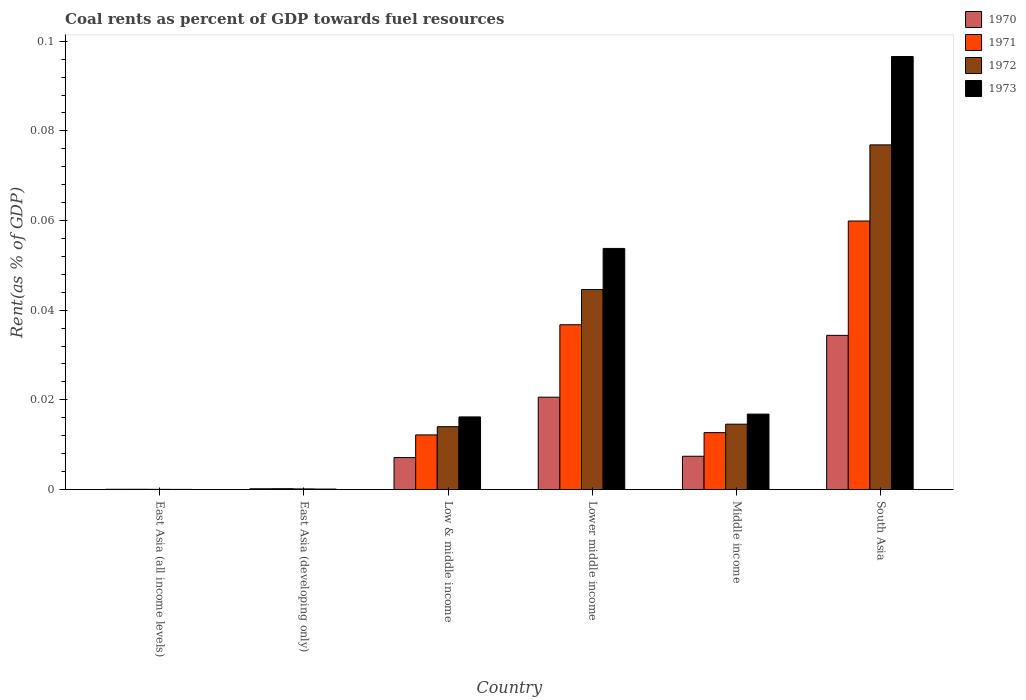How many different coloured bars are there?
Offer a terse response. 4. What is the label of the 5th group of bars from the left?
Your answer should be compact. Middle income. In how many cases, is the number of bars for a given country not equal to the number of legend labels?
Your answer should be very brief. 0. What is the coal rent in 1970 in Low & middle income?
Give a very brief answer. 0.01. Across all countries, what is the maximum coal rent in 1971?
Provide a succinct answer. 0.06. Across all countries, what is the minimum coal rent in 1970?
Give a very brief answer. 5.1314079013758e-5. In which country was the coal rent in 1970 minimum?
Make the answer very short. East Asia (all income levels). What is the total coal rent in 1972 in the graph?
Your answer should be compact. 0.15. What is the difference between the coal rent in 1970 in East Asia (all income levels) and that in East Asia (developing only)?
Make the answer very short. -0. What is the difference between the coal rent in 1970 in Lower middle income and the coal rent in 1972 in East Asia (developing only)?
Ensure brevity in your answer.  0.02. What is the average coal rent in 1970 per country?
Provide a succinct answer. 0.01. What is the difference between the coal rent of/in 1970 and coal rent of/in 1972 in Low & middle income?
Ensure brevity in your answer.  -0.01. What is the ratio of the coal rent in 1971 in East Asia (developing only) to that in Low & middle income?
Provide a succinct answer. 0.02. Is the coal rent in 1973 in East Asia (all income levels) less than that in East Asia (developing only)?
Ensure brevity in your answer.  Yes. What is the difference between the highest and the second highest coal rent in 1971?
Give a very brief answer. 0.05. What is the difference between the highest and the lowest coal rent in 1970?
Keep it short and to the point. 0.03. Is it the case that in every country, the sum of the coal rent in 1971 and coal rent in 1972 is greater than the sum of coal rent in 1973 and coal rent in 1970?
Your answer should be compact. No. What does the 4th bar from the left in Lower middle income represents?
Make the answer very short. 1973. Is it the case that in every country, the sum of the coal rent in 1973 and coal rent in 1972 is greater than the coal rent in 1971?
Your answer should be very brief. Yes. Are all the bars in the graph horizontal?
Your answer should be very brief. No. How many countries are there in the graph?
Offer a very short reply. 6. How are the legend labels stacked?
Your answer should be very brief. Vertical. What is the title of the graph?
Offer a terse response. Coal rents as percent of GDP towards fuel resources. Does "2006" appear as one of the legend labels in the graph?
Keep it short and to the point. No. What is the label or title of the Y-axis?
Keep it short and to the point. Rent(as % of GDP). What is the Rent(as % of GDP) of 1970 in East Asia (all income levels)?
Keep it short and to the point. 5.1314079013758e-5. What is the Rent(as % of GDP) in 1971 in East Asia (all income levels)?
Keep it short and to the point. 5.470114168356261e-5. What is the Rent(as % of GDP) in 1972 in East Asia (all income levels)?
Keep it short and to the point. 3.67730514806032e-5. What is the Rent(as % of GDP) of 1973 in East Asia (all income levels)?
Offer a terse response. 2.64171247686014e-5. What is the Rent(as % of GDP) of 1970 in East Asia (developing only)?
Offer a very short reply. 0. What is the Rent(as % of GDP) of 1971 in East Asia (developing only)?
Provide a short and direct response. 0. What is the Rent(as % of GDP) in 1972 in East Asia (developing only)?
Your answer should be compact. 0. What is the Rent(as % of GDP) of 1973 in East Asia (developing only)?
Make the answer very short. 0. What is the Rent(as % of GDP) of 1970 in Low & middle income?
Offer a very short reply. 0.01. What is the Rent(as % of GDP) in 1971 in Low & middle income?
Keep it short and to the point. 0.01. What is the Rent(as % of GDP) of 1972 in Low & middle income?
Provide a succinct answer. 0.01. What is the Rent(as % of GDP) in 1973 in Low & middle income?
Ensure brevity in your answer.  0.02. What is the Rent(as % of GDP) in 1970 in Lower middle income?
Your response must be concise. 0.02. What is the Rent(as % of GDP) of 1971 in Lower middle income?
Ensure brevity in your answer.  0.04. What is the Rent(as % of GDP) of 1972 in Lower middle income?
Keep it short and to the point. 0.04. What is the Rent(as % of GDP) of 1973 in Lower middle income?
Your answer should be very brief. 0.05. What is the Rent(as % of GDP) of 1970 in Middle income?
Provide a short and direct response. 0.01. What is the Rent(as % of GDP) of 1971 in Middle income?
Make the answer very short. 0.01. What is the Rent(as % of GDP) in 1972 in Middle income?
Make the answer very short. 0.01. What is the Rent(as % of GDP) in 1973 in Middle income?
Your answer should be compact. 0.02. What is the Rent(as % of GDP) of 1970 in South Asia?
Keep it short and to the point. 0.03. What is the Rent(as % of GDP) of 1971 in South Asia?
Your answer should be very brief. 0.06. What is the Rent(as % of GDP) in 1972 in South Asia?
Make the answer very short. 0.08. What is the Rent(as % of GDP) in 1973 in South Asia?
Ensure brevity in your answer.  0.1. Across all countries, what is the maximum Rent(as % of GDP) of 1970?
Your response must be concise. 0.03. Across all countries, what is the maximum Rent(as % of GDP) in 1971?
Your answer should be compact. 0.06. Across all countries, what is the maximum Rent(as % of GDP) in 1972?
Provide a succinct answer. 0.08. Across all countries, what is the maximum Rent(as % of GDP) in 1973?
Give a very brief answer. 0.1. Across all countries, what is the minimum Rent(as % of GDP) of 1970?
Provide a short and direct response. 5.1314079013758e-5. Across all countries, what is the minimum Rent(as % of GDP) in 1971?
Your answer should be very brief. 5.470114168356261e-5. Across all countries, what is the minimum Rent(as % of GDP) of 1972?
Ensure brevity in your answer.  3.67730514806032e-5. Across all countries, what is the minimum Rent(as % of GDP) of 1973?
Your response must be concise. 2.64171247686014e-5. What is the total Rent(as % of GDP) in 1970 in the graph?
Make the answer very short. 0.07. What is the total Rent(as % of GDP) in 1971 in the graph?
Your answer should be very brief. 0.12. What is the total Rent(as % of GDP) in 1972 in the graph?
Provide a succinct answer. 0.15. What is the total Rent(as % of GDP) of 1973 in the graph?
Your response must be concise. 0.18. What is the difference between the Rent(as % of GDP) of 1970 in East Asia (all income levels) and that in East Asia (developing only)?
Make the answer very short. -0. What is the difference between the Rent(as % of GDP) of 1971 in East Asia (all income levels) and that in East Asia (developing only)?
Ensure brevity in your answer.  -0. What is the difference between the Rent(as % of GDP) of 1972 in East Asia (all income levels) and that in East Asia (developing only)?
Offer a very short reply. -0. What is the difference between the Rent(as % of GDP) in 1973 in East Asia (all income levels) and that in East Asia (developing only)?
Offer a very short reply. -0. What is the difference between the Rent(as % of GDP) in 1970 in East Asia (all income levels) and that in Low & middle income?
Make the answer very short. -0.01. What is the difference between the Rent(as % of GDP) in 1971 in East Asia (all income levels) and that in Low & middle income?
Your response must be concise. -0.01. What is the difference between the Rent(as % of GDP) in 1972 in East Asia (all income levels) and that in Low & middle income?
Your response must be concise. -0.01. What is the difference between the Rent(as % of GDP) in 1973 in East Asia (all income levels) and that in Low & middle income?
Ensure brevity in your answer.  -0.02. What is the difference between the Rent(as % of GDP) of 1970 in East Asia (all income levels) and that in Lower middle income?
Ensure brevity in your answer.  -0.02. What is the difference between the Rent(as % of GDP) of 1971 in East Asia (all income levels) and that in Lower middle income?
Provide a short and direct response. -0.04. What is the difference between the Rent(as % of GDP) of 1972 in East Asia (all income levels) and that in Lower middle income?
Make the answer very short. -0.04. What is the difference between the Rent(as % of GDP) of 1973 in East Asia (all income levels) and that in Lower middle income?
Give a very brief answer. -0.05. What is the difference between the Rent(as % of GDP) of 1970 in East Asia (all income levels) and that in Middle income?
Offer a very short reply. -0.01. What is the difference between the Rent(as % of GDP) of 1971 in East Asia (all income levels) and that in Middle income?
Offer a very short reply. -0.01. What is the difference between the Rent(as % of GDP) in 1972 in East Asia (all income levels) and that in Middle income?
Your response must be concise. -0.01. What is the difference between the Rent(as % of GDP) in 1973 in East Asia (all income levels) and that in Middle income?
Keep it short and to the point. -0.02. What is the difference between the Rent(as % of GDP) of 1970 in East Asia (all income levels) and that in South Asia?
Make the answer very short. -0.03. What is the difference between the Rent(as % of GDP) in 1971 in East Asia (all income levels) and that in South Asia?
Keep it short and to the point. -0.06. What is the difference between the Rent(as % of GDP) in 1972 in East Asia (all income levels) and that in South Asia?
Your answer should be compact. -0.08. What is the difference between the Rent(as % of GDP) of 1973 in East Asia (all income levels) and that in South Asia?
Offer a terse response. -0.1. What is the difference between the Rent(as % of GDP) of 1970 in East Asia (developing only) and that in Low & middle income?
Ensure brevity in your answer.  -0.01. What is the difference between the Rent(as % of GDP) of 1971 in East Asia (developing only) and that in Low & middle income?
Offer a very short reply. -0.01. What is the difference between the Rent(as % of GDP) in 1972 in East Asia (developing only) and that in Low & middle income?
Offer a terse response. -0.01. What is the difference between the Rent(as % of GDP) of 1973 in East Asia (developing only) and that in Low & middle income?
Offer a terse response. -0.02. What is the difference between the Rent(as % of GDP) in 1970 in East Asia (developing only) and that in Lower middle income?
Your answer should be compact. -0.02. What is the difference between the Rent(as % of GDP) of 1971 in East Asia (developing only) and that in Lower middle income?
Your answer should be compact. -0.04. What is the difference between the Rent(as % of GDP) in 1972 in East Asia (developing only) and that in Lower middle income?
Offer a very short reply. -0.04. What is the difference between the Rent(as % of GDP) of 1973 in East Asia (developing only) and that in Lower middle income?
Your answer should be compact. -0.05. What is the difference between the Rent(as % of GDP) in 1970 in East Asia (developing only) and that in Middle income?
Offer a very short reply. -0.01. What is the difference between the Rent(as % of GDP) in 1971 in East Asia (developing only) and that in Middle income?
Your response must be concise. -0.01. What is the difference between the Rent(as % of GDP) in 1972 in East Asia (developing only) and that in Middle income?
Keep it short and to the point. -0.01. What is the difference between the Rent(as % of GDP) in 1973 in East Asia (developing only) and that in Middle income?
Ensure brevity in your answer.  -0.02. What is the difference between the Rent(as % of GDP) of 1970 in East Asia (developing only) and that in South Asia?
Give a very brief answer. -0.03. What is the difference between the Rent(as % of GDP) in 1971 in East Asia (developing only) and that in South Asia?
Make the answer very short. -0.06. What is the difference between the Rent(as % of GDP) of 1972 in East Asia (developing only) and that in South Asia?
Make the answer very short. -0.08. What is the difference between the Rent(as % of GDP) in 1973 in East Asia (developing only) and that in South Asia?
Offer a very short reply. -0.1. What is the difference between the Rent(as % of GDP) in 1970 in Low & middle income and that in Lower middle income?
Your response must be concise. -0.01. What is the difference between the Rent(as % of GDP) of 1971 in Low & middle income and that in Lower middle income?
Offer a terse response. -0.02. What is the difference between the Rent(as % of GDP) in 1972 in Low & middle income and that in Lower middle income?
Ensure brevity in your answer.  -0.03. What is the difference between the Rent(as % of GDP) of 1973 in Low & middle income and that in Lower middle income?
Make the answer very short. -0.04. What is the difference between the Rent(as % of GDP) in 1970 in Low & middle income and that in Middle income?
Provide a short and direct response. -0. What is the difference between the Rent(as % of GDP) in 1971 in Low & middle income and that in Middle income?
Provide a short and direct response. -0. What is the difference between the Rent(as % of GDP) of 1972 in Low & middle income and that in Middle income?
Make the answer very short. -0. What is the difference between the Rent(as % of GDP) in 1973 in Low & middle income and that in Middle income?
Keep it short and to the point. -0. What is the difference between the Rent(as % of GDP) of 1970 in Low & middle income and that in South Asia?
Your answer should be compact. -0.03. What is the difference between the Rent(as % of GDP) of 1971 in Low & middle income and that in South Asia?
Your response must be concise. -0.05. What is the difference between the Rent(as % of GDP) in 1972 in Low & middle income and that in South Asia?
Your answer should be compact. -0.06. What is the difference between the Rent(as % of GDP) in 1973 in Low & middle income and that in South Asia?
Offer a very short reply. -0.08. What is the difference between the Rent(as % of GDP) in 1970 in Lower middle income and that in Middle income?
Keep it short and to the point. 0.01. What is the difference between the Rent(as % of GDP) of 1971 in Lower middle income and that in Middle income?
Keep it short and to the point. 0.02. What is the difference between the Rent(as % of GDP) in 1973 in Lower middle income and that in Middle income?
Provide a short and direct response. 0.04. What is the difference between the Rent(as % of GDP) in 1970 in Lower middle income and that in South Asia?
Your answer should be compact. -0.01. What is the difference between the Rent(as % of GDP) of 1971 in Lower middle income and that in South Asia?
Provide a succinct answer. -0.02. What is the difference between the Rent(as % of GDP) of 1972 in Lower middle income and that in South Asia?
Keep it short and to the point. -0.03. What is the difference between the Rent(as % of GDP) in 1973 in Lower middle income and that in South Asia?
Provide a short and direct response. -0.04. What is the difference between the Rent(as % of GDP) of 1970 in Middle income and that in South Asia?
Keep it short and to the point. -0.03. What is the difference between the Rent(as % of GDP) of 1971 in Middle income and that in South Asia?
Provide a succinct answer. -0.05. What is the difference between the Rent(as % of GDP) in 1972 in Middle income and that in South Asia?
Your response must be concise. -0.06. What is the difference between the Rent(as % of GDP) of 1973 in Middle income and that in South Asia?
Your answer should be compact. -0.08. What is the difference between the Rent(as % of GDP) in 1970 in East Asia (all income levels) and the Rent(as % of GDP) in 1971 in East Asia (developing only)?
Provide a succinct answer. -0. What is the difference between the Rent(as % of GDP) of 1970 in East Asia (all income levels) and the Rent(as % of GDP) of 1972 in East Asia (developing only)?
Offer a very short reply. -0. What is the difference between the Rent(as % of GDP) in 1970 in East Asia (all income levels) and the Rent(as % of GDP) in 1973 in East Asia (developing only)?
Your response must be concise. -0. What is the difference between the Rent(as % of GDP) of 1971 in East Asia (all income levels) and the Rent(as % of GDP) of 1972 in East Asia (developing only)?
Your answer should be compact. -0. What is the difference between the Rent(as % of GDP) in 1972 in East Asia (all income levels) and the Rent(as % of GDP) in 1973 in East Asia (developing only)?
Provide a succinct answer. -0. What is the difference between the Rent(as % of GDP) of 1970 in East Asia (all income levels) and the Rent(as % of GDP) of 1971 in Low & middle income?
Offer a very short reply. -0.01. What is the difference between the Rent(as % of GDP) of 1970 in East Asia (all income levels) and the Rent(as % of GDP) of 1972 in Low & middle income?
Your response must be concise. -0.01. What is the difference between the Rent(as % of GDP) in 1970 in East Asia (all income levels) and the Rent(as % of GDP) in 1973 in Low & middle income?
Keep it short and to the point. -0.02. What is the difference between the Rent(as % of GDP) in 1971 in East Asia (all income levels) and the Rent(as % of GDP) in 1972 in Low & middle income?
Keep it short and to the point. -0.01. What is the difference between the Rent(as % of GDP) in 1971 in East Asia (all income levels) and the Rent(as % of GDP) in 1973 in Low & middle income?
Your answer should be compact. -0.02. What is the difference between the Rent(as % of GDP) of 1972 in East Asia (all income levels) and the Rent(as % of GDP) of 1973 in Low & middle income?
Keep it short and to the point. -0.02. What is the difference between the Rent(as % of GDP) in 1970 in East Asia (all income levels) and the Rent(as % of GDP) in 1971 in Lower middle income?
Provide a short and direct response. -0.04. What is the difference between the Rent(as % of GDP) in 1970 in East Asia (all income levels) and the Rent(as % of GDP) in 1972 in Lower middle income?
Offer a terse response. -0.04. What is the difference between the Rent(as % of GDP) of 1970 in East Asia (all income levels) and the Rent(as % of GDP) of 1973 in Lower middle income?
Your response must be concise. -0.05. What is the difference between the Rent(as % of GDP) of 1971 in East Asia (all income levels) and the Rent(as % of GDP) of 1972 in Lower middle income?
Your response must be concise. -0.04. What is the difference between the Rent(as % of GDP) of 1971 in East Asia (all income levels) and the Rent(as % of GDP) of 1973 in Lower middle income?
Your answer should be very brief. -0.05. What is the difference between the Rent(as % of GDP) of 1972 in East Asia (all income levels) and the Rent(as % of GDP) of 1973 in Lower middle income?
Keep it short and to the point. -0.05. What is the difference between the Rent(as % of GDP) of 1970 in East Asia (all income levels) and the Rent(as % of GDP) of 1971 in Middle income?
Your answer should be very brief. -0.01. What is the difference between the Rent(as % of GDP) in 1970 in East Asia (all income levels) and the Rent(as % of GDP) in 1972 in Middle income?
Provide a short and direct response. -0.01. What is the difference between the Rent(as % of GDP) in 1970 in East Asia (all income levels) and the Rent(as % of GDP) in 1973 in Middle income?
Your response must be concise. -0.02. What is the difference between the Rent(as % of GDP) in 1971 in East Asia (all income levels) and the Rent(as % of GDP) in 1972 in Middle income?
Offer a very short reply. -0.01. What is the difference between the Rent(as % of GDP) of 1971 in East Asia (all income levels) and the Rent(as % of GDP) of 1973 in Middle income?
Your answer should be compact. -0.02. What is the difference between the Rent(as % of GDP) of 1972 in East Asia (all income levels) and the Rent(as % of GDP) of 1973 in Middle income?
Offer a very short reply. -0.02. What is the difference between the Rent(as % of GDP) in 1970 in East Asia (all income levels) and the Rent(as % of GDP) in 1971 in South Asia?
Your response must be concise. -0.06. What is the difference between the Rent(as % of GDP) of 1970 in East Asia (all income levels) and the Rent(as % of GDP) of 1972 in South Asia?
Provide a short and direct response. -0.08. What is the difference between the Rent(as % of GDP) of 1970 in East Asia (all income levels) and the Rent(as % of GDP) of 1973 in South Asia?
Provide a short and direct response. -0.1. What is the difference between the Rent(as % of GDP) in 1971 in East Asia (all income levels) and the Rent(as % of GDP) in 1972 in South Asia?
Give a very brief answer. -0.08. What is the difference between the Rent(as % of GDP) in 1971 in East Asia (all income levels) and the Rent(as % of GDP) in 1973 in South Asia?
Provide a short and direct response. -0.1. What is the difference between the Rent(as % of GDP) of 1972 in East Asia (all income levels) and the Rent(as % of GDP) of 1973 in South Asia?
Provide a succinct answer. -0.1. What is the difference between the Rent(as % of GDP) of 1970 in East Asia (developing only) and the Rent(as % of GDP) of 1971 in Low & middle income?
Provide a succinct answer. -0.01. What is the difference between the Rent(as % of GDP) of 1970 in East Asia (developing only) and the Rent(as % of GDP) of 1972 in Low & middle income?
Offer a terse response. -0.01. What is the difference between the Rent(as % of GDP) in 1970 in East Asia (developing only) and the Rent(as % of GDP) in 1973 in Low & middle income?
Provide a succinct answer. -0.02. What is the difference between the Rent(as % of GDP) of 1971 in East Asia (developing only) and the Rent(as % of GDP) of 1972 in Low & middle income?
Your answer should be compact. -0.01. What is the difference between the Rent(as % of GDP) of 1971 in East Asia (developing only) and the Rent(as % of GDP) of 1973 in Low & middle income?
Offer a terse response. -0.02. What is the difference between the Rent(as % of GDP) of 1972 in East Asia (developing only) and the Rent(as % of GDP) of 1973 in Low & middle income?
Offer a very short reply. -0.02. What is the difference between the Rent(as % of GDP) in 1970 in East Asia (developing only) and the Rent(as % of GDP) in 1971 in Lower middle income?
Make the answer very short. -0.04. What is the difference between the Rent(as % of GDP) in 1970 in East Asia (developing only) and the Rent(as % of GDP) in 1972 in Lower middle income?
Provide a succinct answer. -0.04. What is the difference between the Rent(as % of GDP) of 1970 in East Asia (developing only) and the Rent(as % of GDP) of 1973 in Lower middle income?
Your answer should be compact. -0.05. What is the difference between the Rent(as % of GDP) in 1971 in East Asia (developing only) and the Rent(as % of GDP) in 1972 in Lower middle income?
Your answer should be compact. -0.04. What is the difference between the Rent(as % of GDP) of 1971 in East Asia (developing only) and the Rent(as % of GDP) of 1973 in Lower middle income?
Make the answer very short. -0.05. What is the difference between the Rent(as % of GDP) in 1972 in East Asia (developing only) and the Rent(as % of GDP) in 1973 in Lower middle income?
Give a very brief answer. -0.05. What is the difference between the Rent(as % of GDP) in 1970 in East Asia (developing only) and the Rent(as % of GDP) in 1971 in Middle income?
Provide a short and direct response. -0.01. What is the difference between the Rent(as % of GDP) of 1970 in East Asia (developing only) and the Rent(as % of GDP) of 1972 in Middle income?
Provide a short and direct response. -0.01. What is the difference between the Rent(as % of GDP) of 1970 in East Asia (developing only) and the Rent(as % of GDP) of 1973 in Middle income?
Offer a very short reply. -0.02. What is the difference between the Rent(as % of GDP) of 1971 in East Asia (developing only) and the Rent(as % of GDP) of 1972 in Middle income?
Provide a succinct answer. -0.01. What is the difference between the Rent(as % of GDP) in 1971 in East Asia (developing only) and the Rent(as % of GDP) in 1973 in Middle income?
Your response must be concise. -0.02. What is the difference between the Rent(as % of GDP) of 1972 in East Asia (developing only) and the Rent(as % of GDP) of 1973 in Middle income?
Keep it short and to the point. -0.02. What is the difference between the Rent(as % of GDP) of 1970 in East Asia (developing only) and the Rent(as % of GDP) of 1971 in South Asia?
Your answer should be very brief. -0.06. What is the difference between the Rent(as % of GDP) in 1970 in East Asia (developing only) and the Rent(as % of GDP) in 1972 in South Asia?
Your answer should be compact. -0.08. What is the difference between the Rent(as % of GDP) of 1970 in East Asia (developing only) and the Rent(as % of GDP) of 1973 in South Asia?
Provide a short and direct response. -0.1. What is the difference between the Rent(as % of GDP) in 1971 in East Asia (developing only) and the Rent(as % of GDP) in 1972 in South Asia?
Your answer should be very brief. -0.08. What is the difference between the Rent(as % of GDP) in 1971 in East Asia (developing only) and the Rent(as % of GDP) in 1973 in South Asia?
Offer a terse response. -0.1. What is the difference between the Rent(as % of GDP) in 1972 in East Asia (developing only) and the Rent(as % of GDP) in 1973 in South Asia?
Provide a succinct answer. -0.1. What is the difference between the Rent(as % of GDP) in 1970 in Low & middle income and the Rent(as % of GDP) in 1971 in Lower middle income?
Provide a succinct answer. -0.03. What is the difference between the Rent(as % of GDP) in 1970 in Low & middle income and the Rent(as % of GDP) in 1972 in Lower middle income?
Offer a terse response. -0.04. What is the difference between the Rent(as % of GDP) of 1970 in Low & middle income and the Rent(as % of GDP) of 1973 in Lower middle income?
Give a very brief answer. -0.05. What is the difference between the Rent(as % of GDP) in 1971 in Low & middle income and the Rent(as % of GDP) in 1972 in Lower middle income?
Offer a terse response. -0.03. What is the difference between the Rent(as % of GDP) in 1971 in Low & middle income and the Rent(as % of GDP) in 1973 in Lower middle income?
Offer a very short reply. -0.04. What is the difference between the Rent(as % of GDP) of 1972 in Low & middle income and the Rent(as % of GDP) of 1973 in Lower middle income?
Your response must be concise. -0.04. What is the difference between the Rent(as % of GDP) in 1970 in Low & middle income and the Rent(as % of GDP) in 1971 in Middle income?
Make the answer very short. -0.01. What is the difference between the Rent(as % of GDP) in 1970 in Low & middle income and the Rent(as % of GDP) in 1972 in Middle income?
Provide a short and direct response. -0.01. What is the difference between the Rent(as % of GDP) of 1970 in Low & middle income and the Rent(as % of GDP) of 1973 in Middle income?
Your response must be concise. -0.01. What is the difference between the Rent(as % of GDP) of 1971 in Low & middle income and the Rent(as % of GDP) of 1972 in Middle income?
Your answer should be compact. -0. What is the difference between the Rent(as % of GDP) in 1971 in Low & middle income and the Rent(as % of GDP) in 1973 in Middle income?
Ensure brevity in your answer.  -0. What is the difference between the Rent(as % of GDP) in 1972 in Low & middle income and the Rent(as % of GDP) in 1973 in Middle income?
Provide a succinct answer. -0. What is the difference between the Rent(as % of GDP) of 1970 in Low & middle income and the Rent(as % of GDP) of 1971 in South Asia?
Provide a succinct answer. -0.05. What is the difference between the Rent(as % of GDP) in 1970 in Low & middle income and the Rent(as % of GDP) in 1972 in South Asia?
Give a very brief answer. -0.07. What is the difference between the Rent(as % of GDP) of 1970 in Low & middle income and the Rent(as % of GDP) of 1973 in South Asia?
Offer a terse response. -0.09. What is the difference between the Rent(as % of GDP) of 1971 in Low & middle income and the Rent(as % of GDP) of 1972 in South Asia?
Give a very brief answer. -0.06. What is the difference between the Rent(as % of GDP) of 1971 in Low & middle income and the Rent(as % of GDP) of 1973 in South Asia?
Ensure brevity in your answer.  -0.08. What is the difference between the Rent(as % of GDP) of 1972 in Low & middle income and the Rent(as % of GDP) of 1973 in South Asia?
Your answer should be compact. -0.08. What is the difference between the Rent(as % of GDP) of 1970 in Lower middle income and the Rent(as % of GDP) of 1971 in Middle income?
Provide a succinct answer. 0.01. What is the difference between the Rent(as % of GDP) in 1970 in Lower middle income and the Rent(as % of GDP) in 1972 in Middle income?
Your answer should be very brief. 0.01. What is the difference between the Rent(as % of GDP) of 1970 in Lower middle income and the Rent(as % of GDP) of 1973 in Middle income?
Provide a succinct answer. 0. What is the difference between the Rent(as % of GDP) in 1971 in Lower middle income and the Rent(as % of GDP) in 1972 in Middle income?
Provide a succinct answer. 0.02. What is the difference between the Rent(as % of GDP) in 1971 in Lower middle income and the Rent(as % of GDP) in 1973 in Middle income?
Your response must be concise. 0.02. What is the difference between the Rent(as % of GDP) in 1972 in Lower middle income and the Rent(as % of GDP) in 1973 in Middle income?
Give a very brief answer. 0.03. What is the difference between the Rent(as % of GDP) of 1970 in Lower middle income and the Rent(as % of GDP) of 1971 in South Asia?
Offer a terse response. -0.04. What is the difference between the Rent(as % of GDP) in 1970 in Lower middle income and the Rent(as % of GDP) in 1972 in South Asia?
Offer a terse response. -0.06. What is the difference between the Rent(as % of GDP) in 1970 in Lower middle income and the Rent(as % of GDP) in 1973 in South Asia?
Your response must be concise. -0.08. What is the difference between the Rent(as % of GDP) of 1971 in Lower middle income and the Rent(as % of GDP) of 1972 in South Asia?
Your answer should be very brief. -0.04. What is the difference between the Rent(as % of GDP) of 1971 in Lower middle income and the Rent(as % of GDP) of 1973 in South Asia?
Your response must be concise. -0.06. What is the difference between the Rent(as % of GDP) in 1972 in Lower middle income and the Rent(as % of GDP) in 1973 in South Asia?
Provide a succinct answer. -0.05. What is the difference between the Rent(as % of GDP) in 1970 in Middle income and the Rent(as % of GDP) in 1971 in South Asia?
Make the answer very short. -0.05. What is the difference between the Rent(as % of GDP) in 1970 in Middle income and the Rent(as % of GDP) in 1972 in South Asia?
Your answer should be compact. -0.07. What is the difference between the Rent(as % of GDP) of 1970 in Middle income and the Rent(as % of GDP) of 1973 in South Asia?
Your answer should be very brief. -0.09. What is the difference between the Rent(as % of GDP) of 1971 in Middle income and the Rent(as % of GDP) of 1972 in South Asia?
Offer a terse response. -0.06. What is the difference between the Rent(as % of GDP) of 1971 in Middle income and the Rent(as % of GDP) of 1973 in South Asia?
Your response must be concise. -0.08. What is the difference between the Rent(as % of GDP) in 1972 in Middle income and the Rent(as % of GDP) in 1973 in South Asia?
Your answer should be compact. -0.08. What is the average Rent(as % of GDP) of 1970 per country?
Keep it short and to the point. 0.01. What is the average Rent(as % of GDP) of 1971 per country?
Your answer should be very brief. 0.02. What is the average Rent(as % of GDP) of 1972 per country?
Provide a short and direct response. 0.03. What is the average Rent(as % of GDP) in 1973 per country?
Make the answer very short. 0.03. What is the difference between the Rent(as % of GDP) in 1970 and Rent(as % of GDP) in 1971 in East Asia (all income levels)?
Give a very brief answer. -0. What is the difference between the Rent(as % of GDP) in 1970 and Rent(as % of GDP) in 1972 in East Asia (all income levels)?
Offer a very short reply. 0. What is the difference between the Rent(as % of GDP) in 1970 and Rent(as % of GDP) in 1973 in East Asia (developing only)?
Your answer should be very brief. 0. What is the difference between the Rent(as % of GDP) of 1970 and Rent(as % of GDP) of 1971 in Low & middle income?
Provide a succinct answer. -0.01. What is the difference between the Rent(as % of GDP) in 1970 and Rent(as % of GDP) in 1972 in Low & middle income?
Your answer should be compact. -0.01. What is the difference between the Rent(as % of GDP) in 1970 and Rent(as % of GDP) in 1973 in Low & middle income?
Provide a succinct answer. -0.01. What is the difference between the Rent(as % of GDP) of 1971 and Rent(as % of GDP) of 1972 in Low & middle income?
Keep it short and to the point. -0. What is the difference between the Rent(as % of GDP) of 1971 and Rent(as % of GDP) of 1973 in Low & middle income?
Give a very brief answer. -0. What is the difference between the Rent(as % of GDP) of 1972 and Rent(as % of GDP) of 1973 in Low & middle income?
Your answer should be compact. -0. What is the difference between the Rent(as % of GDP) in 1970 and Rent(as % of GDP) in 1971 in Lower middle income?
Your answer should be very brief. -0.02. What is the difference between the Rent(as % of GDP) of 1970 and Rent(as % of GDP) of 1972 in Lower middle income?
Offer a terse response. -0.02. What is the difference between the Rent(as % of GDP) in 1970 and Rent(as % of GDP) in 1973 in Lower middle income?
Your answer should be compact. -0.03. What is the difference between the Rent(as % of GDP) in 1971 and Rent(as % of GDP) in 1972 in Lower middle income?
Provide a succinct answer. -0.01. What is the difference between the Rent(as % of GDP) of 1971 and Rent(as % of GDP) of 1973 in Lower middle income?
Offer a very short reply. -0.02. What is the difference between the Rent(as % of GDP) of 1972 and Rent(as % of GDP) of 1973 in Lower middle income?
Give a very brief answer. -0.01. What is the difference between the Rent(as % of GDP) in 1970 and Rent(as % of GDP) in 1971 in Middle income?
Offer a terse response. -0.01. What is the difference between the Rent(as % of GDP) of 1970 and Rent(as % of GDP) of 1972 in Middle income?
Provide a short and direct response. -0.01. What is the difference between the Rent(as % of GDP) in 1970 and Rent(as % of GDP) in 1973 in Middle income?
Your response must be concise. -0.01. What is the difference between the Rent(as % of GDP) in 1971 and Rent(as % of GDP) in 1972 in Middle income?
Your response must be concise. -0. What is the difference between the Rent(as % of GDP) of 1971 and Rent(as % of GDP) of 1973 in Middle income?
Offer a very short reply. -0. What is the difference between the Rent(as % of GDP) in 1972 and Rent(as % of GDP) in 1973 in Middle income?
Provide a succinct answer. -0. What is the difference between the Rent(as % of GDP) in 1970 and Rent(as % of GDP) in 1971 in South Asia?
Provide a succinct answer. -0.03. What is the difference between the Rent(as % of GDP) of 1970 and Rent(as % of GDP) of 1972 in South Asia?
Offer a very short reply. -0.04. What is the difference between the Rent(as % of GDP) of 1970 and Rent(as % of GDP) of 1973 in South Asia?
Your response must be concise. -0.06. What is the difference between the Rent(as % of GDP) of 1971 and Rent(as % of GDP) of 1972 in South Asia?
Your answer should be very brief. -0.02. What is the difference between the Rent(as % of GDP) in 1971 and Rent(as % of GDP) in 1973 in South Asia?
Keep it short and to the point. -0.04. What is the difference between the Rent(as % of GDP) in 1972 and Rent(as % of GDP) in 1973 in South Asia?
Offer a terse response. -0.02. What is the ratio of the Rent(as % of GDP) of 1970 in East Asia (all income levels) to that in East Asia (developing only)?
Ensure brevity in your answer.  0.31. What is the ratio of the Rent(as % of GDP) of 1971 in East Asia (all income levels) to that in East Asia (developing only)?
Give a very brief answer. 0.29. What is the ratio of the Rent(as % of GDP) in 1972 in East Asia (all income levels) to that in East Asia (developing only)?
Keep it short and to the point. 0.27. What is the ratio of the Rent(as % of GDP) of 1973 in East Asia (all income levels) to that in East Asia (developing only)?
Keep it short and to the point. 0.26. What is the ratio of the Rent(as % of GDP) in 1970 in East Asia (all income levels) to that in Low & middle income?
Provide a short and direct response. 0.01. What is the ratio of the Rent(as % of GDP) in 1971 in East Asia (all income levels) to that in Low & middle income?
Offer a very short reply. 0. What is the ratio of the Rent(as % of GDP) in 1972 in East Asia (all income levels) to that in Low & middle income?
Keep it short and to the point. 0. What is the ratio of the Rent(as % of GDP) of 1973 in East Asia (all income levels) to that in Low & middle income?
Your answer should be compact. 0. What is the ratio of the Rent(as % of GDP) of 1970 in East Asia (all income levels) to that in Lower middle income?
Offer a terse response. 0. What is the ratio of the Rent(as % of GDP) of 1971 in East Asia (all income levels) to that in Lower middle income?
Your response must be concise. 0. What is the ratio of the Rent(as % of GDP) in 1972 in East Asia (all income levels) to that in Lower middle income?
Your answer should be very brief. 0. What is the ratio of the Rent(as % of GDP) in 1970 in East Asia (all income levels) to that in Middle income?
Give a very brief answer. 0.01. What is the ratio of the Rent(as % of GDP) in 1971 in East Asia (all income levels) to that in Middle income?
Provide a short and direct response. 0. What is the ratio of the Rent(as % of GDP) of 1972 in East Asia (all income levels) to that in Middle income?
Keep it short and to the point. 0. What is the ratio of the Rent(as % of GDP) in 1973 in East Asia (all income levels) to that in Middle income?
Your answer should be compact. 0. What is the ratio of the Rent(as % of GDP) in 1970 in East Asia (all income levels) to that in South Asia?
Your answer should be compact. 0. What is the ratio of the Rent(as % of GDP) of 1971 in East Asia (all income levels) to that in South Asia?
Make the answer very short. 0. What is the ratio of the Rent(as % of GDP) in 1970 in East Asia (developing only) to that in Low & middle income?
Your response must be concise. 0.02. What is the ratio of the Rent(as % of GDP) in 1971 in East Asia (developing only) to that in Low & middle income?
Provide a succinct answer. 0.02. What is the ratio of the Rent(as % of GDP) in 1972 in East Asia (developing only) to that in Low & middle income?
Keep it short and to the point. 0.01. What is the ratio of the Rent(as % of GDP) in 1973 in East Asia (developing only) to that in Low & middle income?
Your answer should be very brief. 0.01. What is the ratio of the Rent(as % of GDP) in 1970 in East Asia (developing only) to that in Lower middle income?
Make the answer very short. 0.01. What is the ratio of the Rent(as % of GDP) in 1971 in East Asia (developing only) to that in Lower middle income?
Your answer should be very brief. 0.01. What is the ratio of the Rent(as % of GDP) in 1972 in East Asia (developing only) to that in Lower middle income?
Your answer should be compact. 0. What is the ratio of the Rent(as % of GDP) of 1973 in East Asia (developing only) to that in Lower middle income?
Your answer should be very brief. 0. What is the ratio of the Rent(as % of GDP) in 1970 in East Asia (developing only) to that in Middle income?
Your response must be concise. 0.02. What is the ratio of the Rent(as % of GDP) in 1971 in East Asia (developing only) to that in Middle income?
Offer a terse response. 0.01. What is the ratio of the Rent(as % of GDP) of 1972 in East Asia (developing only) to that in Middle income?
Give a very brief answer. 0.01. What is the ratio of the Rent(as % of GDP) in 1973 in East Asia (developing only) to that in Middle income?
Ensure brevity in your answer.  0.01. What is the ratio of the Rent(as % of GDP) of 1970 in East Asia (developing only) to that in South Asia?
Your answer should be very brief. 0. What is the ratio of the Rent(as % of GDP) in 1971 in East Asia (developing only) to that in South Asia?
Make the answer very short. 0. What is the ratio of the Rent(as % of GDP) of 1972 in East Asia (developing only) to that in South Asia?
Provide a short and direct response. 0. What is the ratio of the Rent(as % of GDP) in 1973 in East Asia (developing only) to that in South Asia?
Your answer should be compact. 0. What is the ratio of the Rent(as % of GDP) in 1970 in Low & middle income to that in Lower middle income?
Offer a very short reply. 0.35. What is the ratio of the Rent(as % of GDP) in 1971 in Low & middle income to that in Lower middle income?
Your response must be concise. 0.33. What is the ratio of the Rent(as % of GDP) in 1972 in Low & middle income to that in Lower middle income?
Give a very brief answer. 0.31. What is the ratio of the Rent(as % of GDP) of 1973 in Low & middle income to that in Lower middle income?
Provide a succinct answer. 0.3. What is the ratio of the Rent(as % of GDP) of 1970 in Low & middle income to that in Middle income?
Your answer should be compact. 0.96. What is the ratio of the Rent(as % of GDP) in 1971 in Low & middle income to that in Middle income?
Make the answer very short. 0.96. What is the ratio of the Rent(as % of GDP) of 1972 in Low & middle income to that in Middle income?
Your answer should be compact. 0.96. What is the ratio of the Rent(as % of GDP) of 1973 in Low & middle income to that in Middle income?
Make the answer very short. 0.96. What is the ratio of the Rent(as % of GDP) in 1970 in Low & middle income to that in South Asia?
Offer a terse response. 0.21. What is the ratio of the Rent(as % of GDP) of 1971 in Low & middle income to that in South Asia?
Your answer should be compact. 0.2. What is the ratio of the Rent(as % of GDP) in 1972 in Low & middle income to that in South Asia?
Make the answer very short. 0.18. What is the ratio of the Rent(as % of GDP) in 1973 in Low & middle income to that in South Asia?
Your answer should be compact. 0.17. What is the ratio of the Rent(as % of GDP) of 1970 in Lower middle income to that in Middle income?
Provide a short and direct response. 2.78. What is the ratio of the Rent(as % of GDP) of 1971 in Lower middle income to that in Middle income?
Make the answer very short. 2.9. What is the ratio of the Rent(as % of GDP) in 1972 in Lower middle income to that in Middle income?
Offer a very short reply. 3.06. What is the ratio of the Rent(as % of GDP) in 1973 in Lower middle income to that in Middle income?
Ensure brevity in your answer.  3.2. What is the ratio of the Rent(as % of GDP) in 1970 in Lower middle income to that in South Asia?
Give a very brief answer. 0.6. What is the ratio of the Rent(as % of GDP) in 1971 in Lower middle income to that in South Asia?
Offer a very short reply. 0.61. What is the ratio of the Rent(as % of GDP) in 1972 in Lower middle income to that in South Asia?
Offer a very short reply. 0.58. What is the ratio of the Rent(as % of GDP) of 1973 in Lower middle income to that in South Asia?
Keep it short and to the point. 0.56. What is the ratio of the Rent(as % of GDP) of 1970 in Middle income to that in South Asia?
Make the answer very short. 0.22. What is the ratio of the Rent(as % of GDP) of 1971 in Middle income to that in South Asia?
Ensure brevity in your answer.  0.21. What is the ratio of the Rent(as % of GDP) in 1972 in Middle income to that in South Asia?
Your answer should be very brief. 0.19. What is the ratio of the Rent(as % of GDP) of 1973 in Middle income to that in South Asia?
Your response must be concise. 0.17. What is the difference between the highest and the second highest Rent(as % of GDP) in 1970?
Your answer should be very brief. 0.01. What is the difference between the highest and the second highest Rent(as % of GDP) in 1971?
Provide a succinct answer. 0.02. What is the difference between the highest and the second highest Rent(as % of GDP) of 1972?
Provide a short and direct response. 0.03. What is the difference between the highest and the second highest Rent(as % of GDP) in 1973?
Offer a very short reply. 0.04. What is the difference between the highest and the lowest Rent(as % of GDP) in 1970?
Give a very brief answer. 0.03. What is the difference between the highest and the lowest Rent(as % of GDP) of 1971?
Your response must be concise. 0.06. What is the difference between the highest and the lowest Rent(as % of GDP) of 1972?
Offer a terse response. 0.08. What is the difference between the highest and the lowest Rent(as % of GDP) in 1973?
Offer a very short reply. 0.1. 